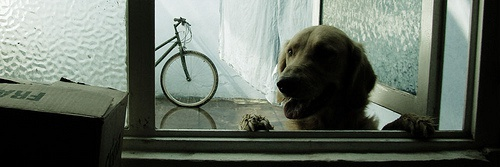Describe the objects in this image and their specific colors. I can see dog in white, black, gray, and darkgreen tones and bicycle in white, darkgray, black, gray, and lightgray tones in this image. 